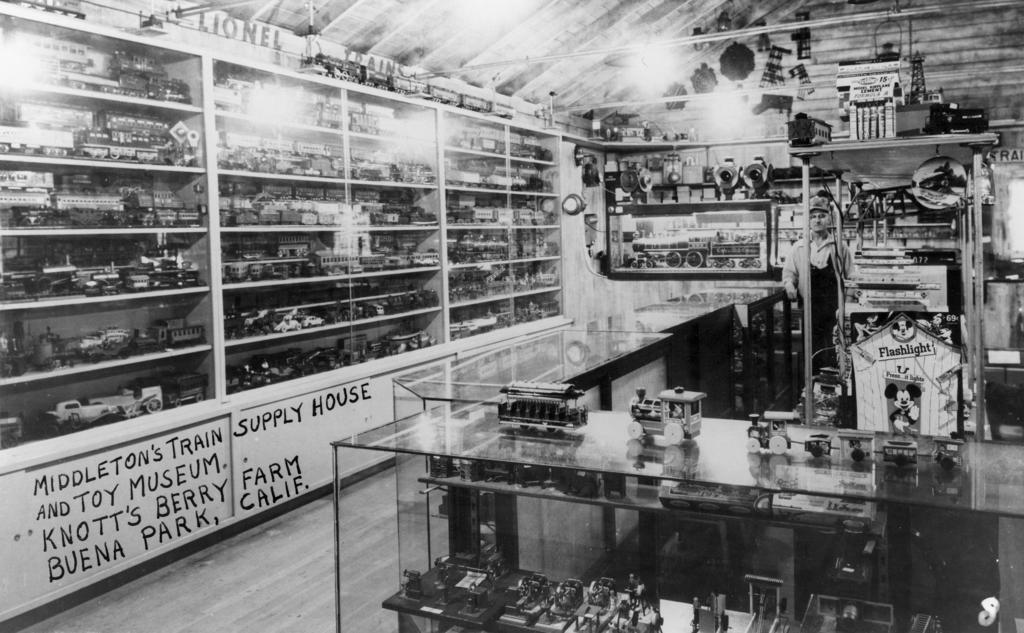Provide a one-sentence caption for the provided image. Shelves with multiple items along with what seems to be model trains and other items around the room. 